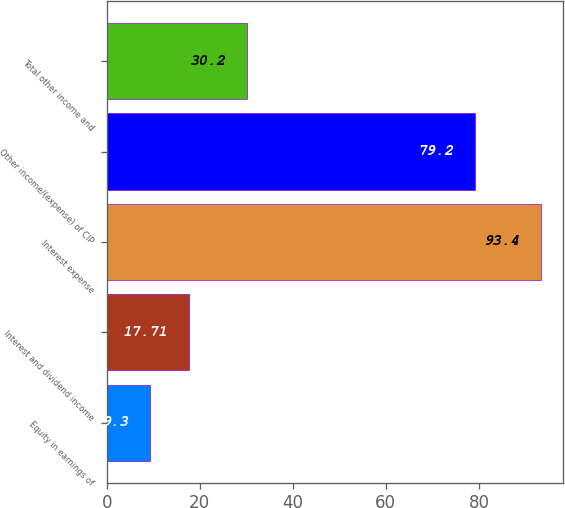Convert chart to OTSL. <chart><loc_0><loc_0><loc_500><loc_500><bar_chart><fcel>Equity in earnings of<fcel>Interest and dividend income<fcel>Interest expense<fcel>Other income/(expense) of CIP<fcel>Total other income and<nl><fcel>9.3<fcel>17.71<fcel>93.4<fcel>79.2<fcel>30.2<nl></chart> 